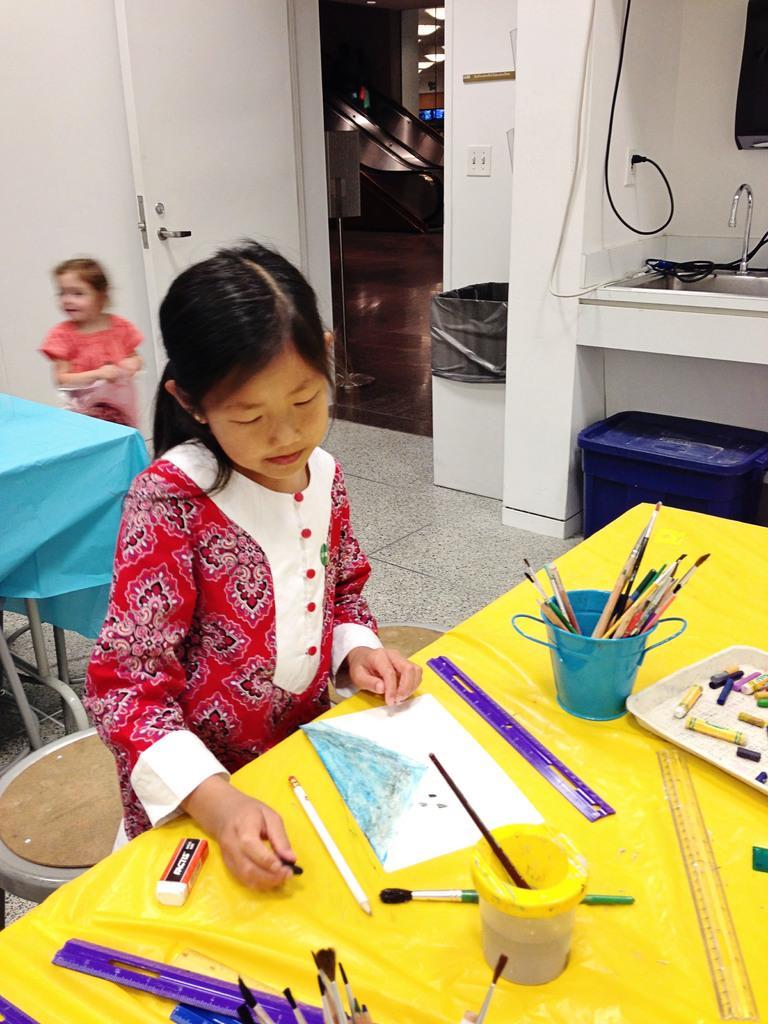How would you summarize this image in a sentence or two? In this image we can see a girl sitting and there is a table in front of her and we can see paint brushes, paper and some other objects on the table. There is a girl in the background and we can see some other objects in the room and there is a door. 